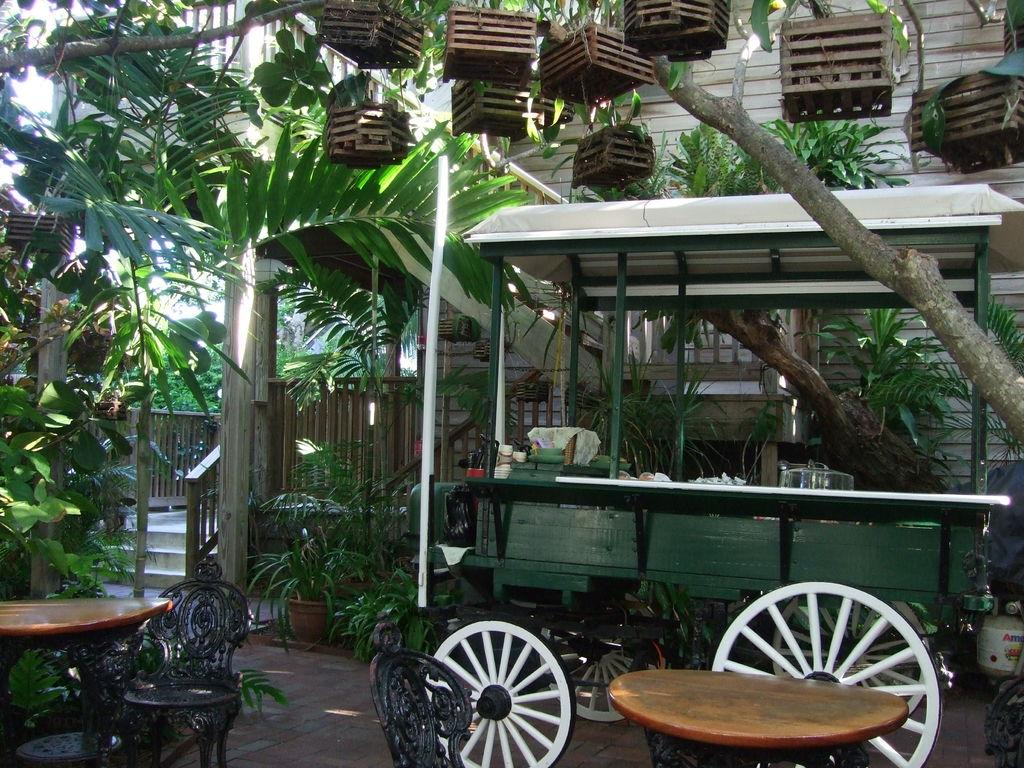What type of vehicle is in the image? There is a cart vehicle in the image. What type of furniture is in the image? There are tables and chairs in the image. What can be seen in the background of the image? There are plants in the background of the image. What type of locket is hanging from the cart vehicle in the image? There is no locket present in the image; it only features a cart vehicle, tables, chairs, and plants in the background. 